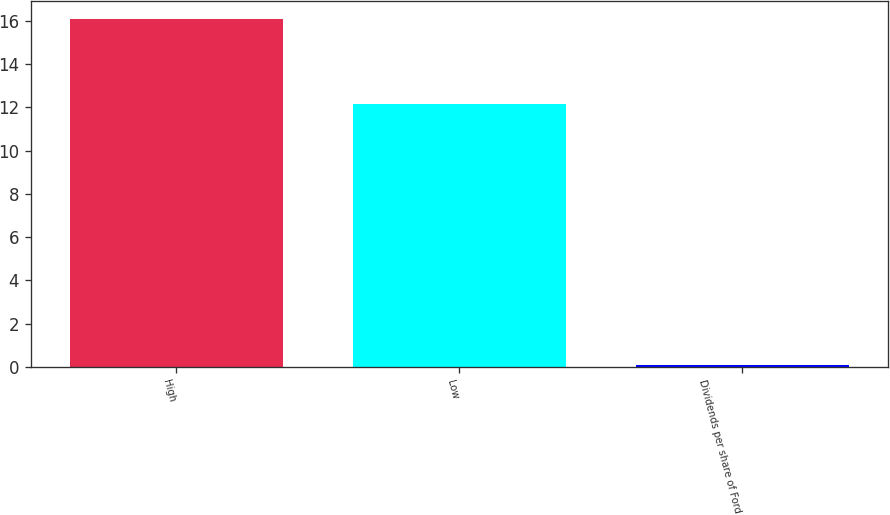<chart> <loc_0><loc_0><loc_500><loc_500><bar_chart><fcel>High<fcel>Low<fcel>Dividends per share of Ford<nl><fcel>16.09<fcel>12.15<fcel>0.1<nl></chart> 